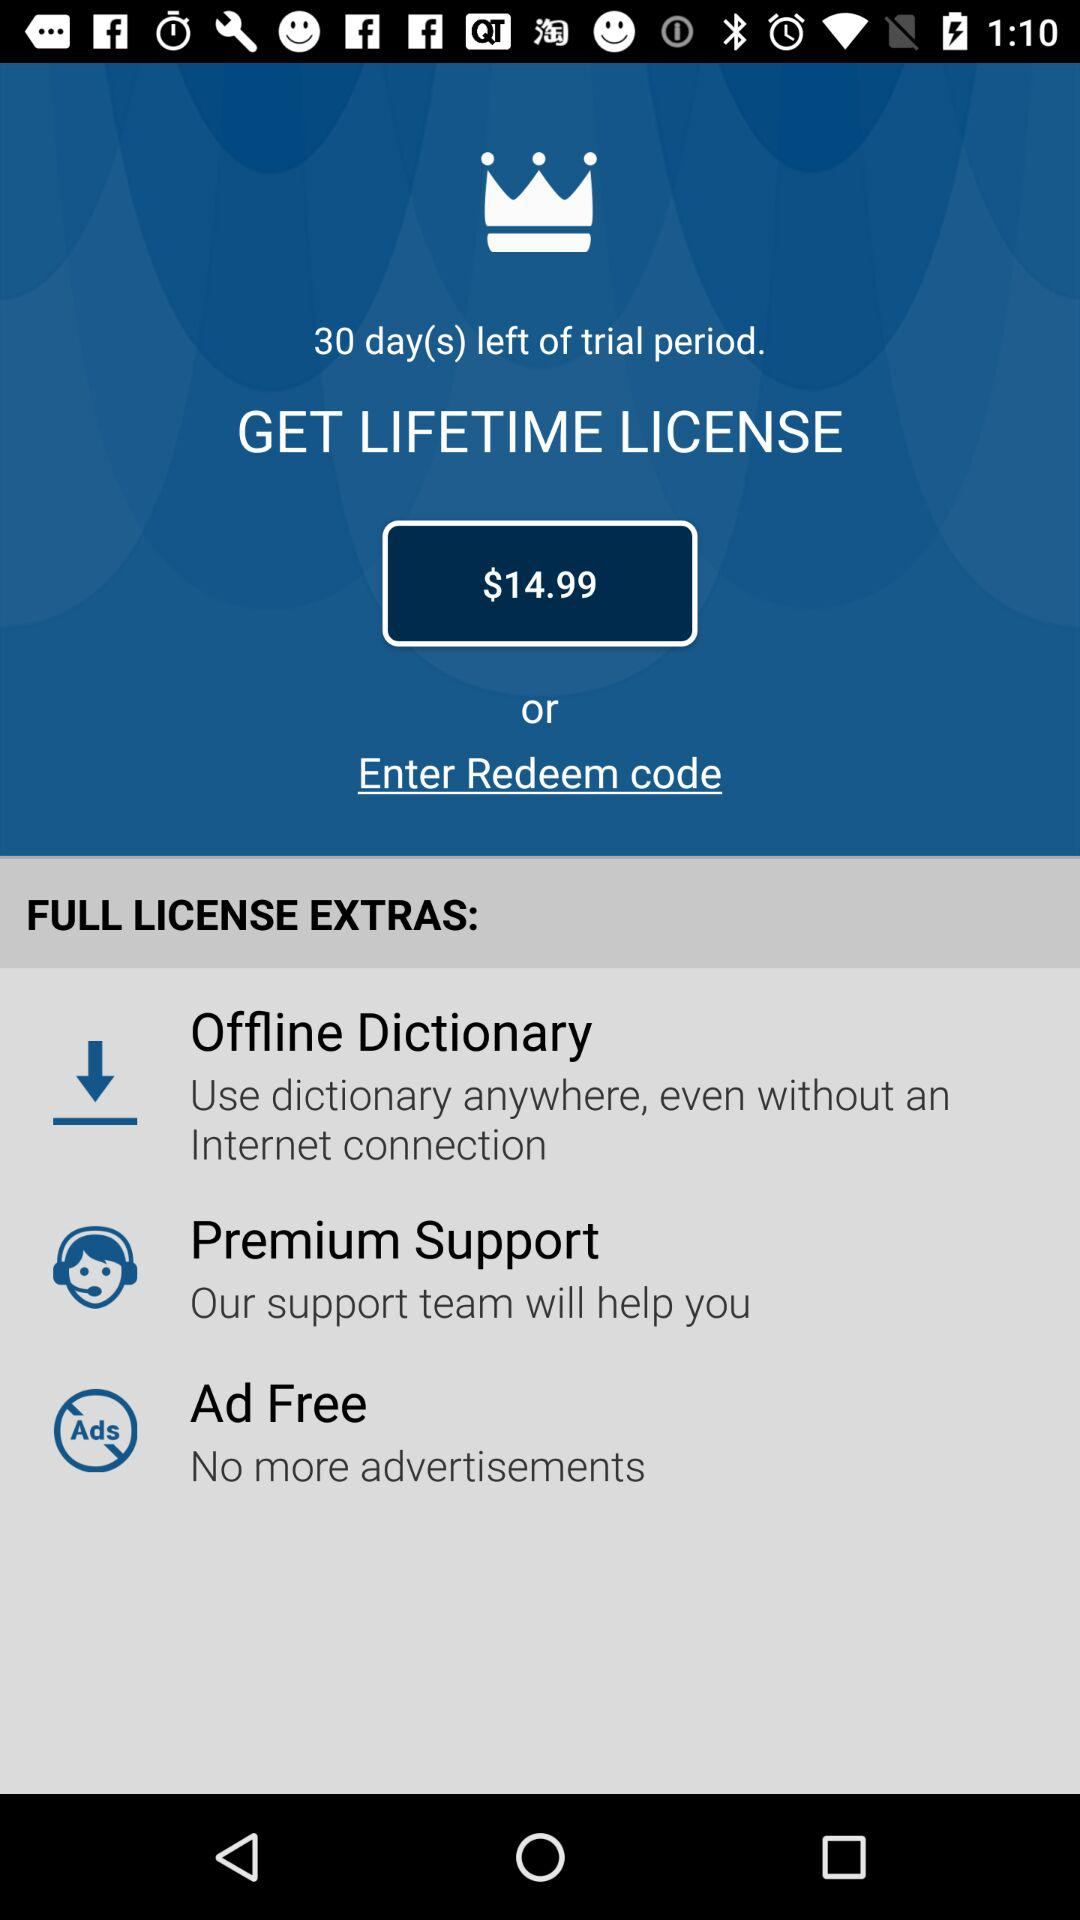What is the description given under the offline dictionary? The description given under the offline dictionary is "Use dictionary anywhere, even without an Internet connection". 